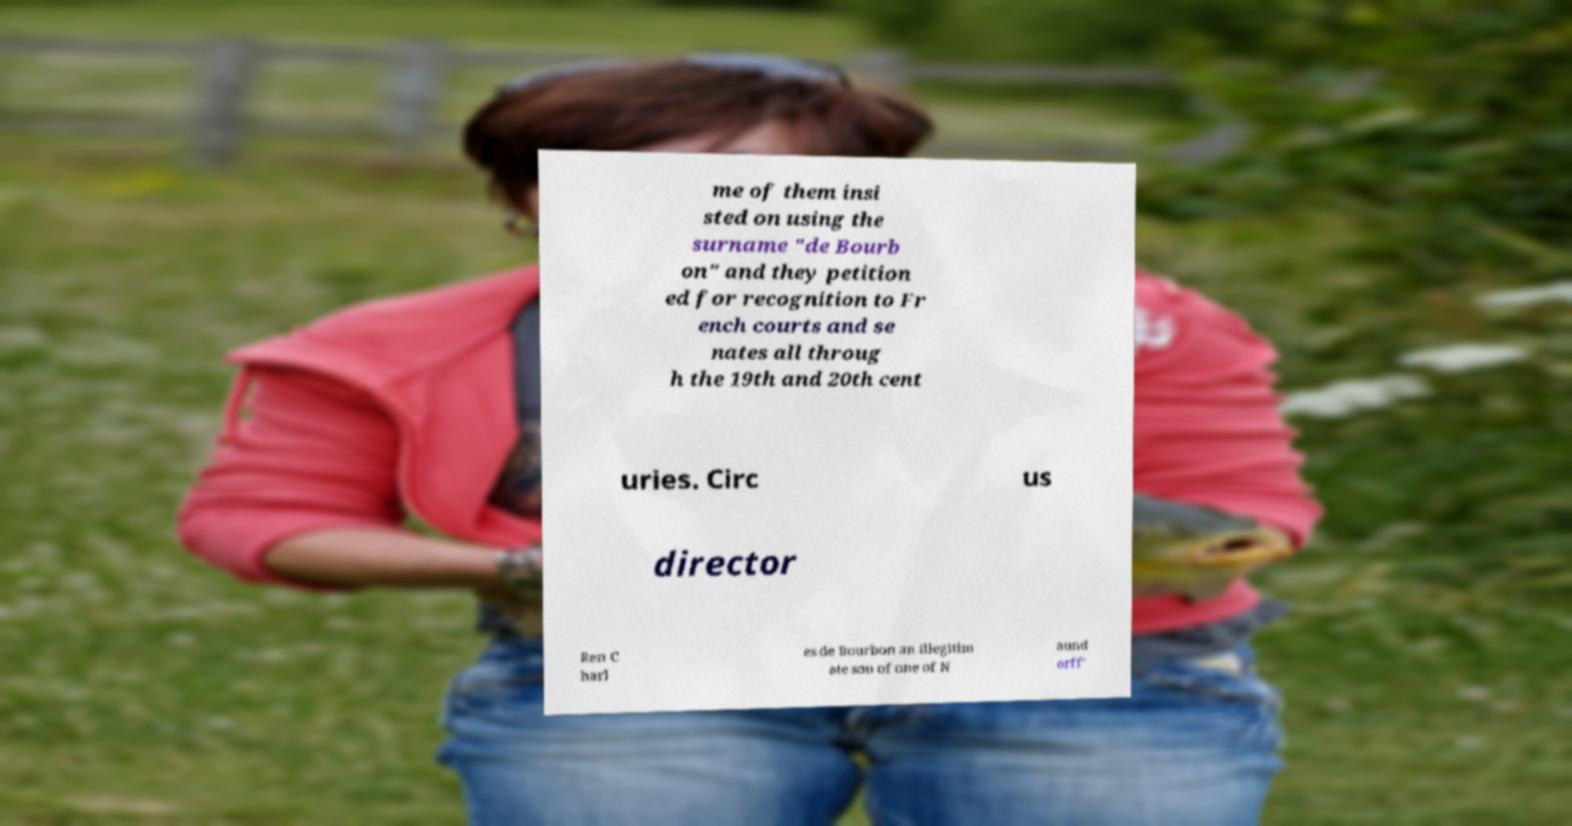I need the written content from this picture converted into text. Can you do that? me of them insi sted on using the surname "de Bourb on" and they petition ed for recognition to Fr ench courts and se nates all throug h the 19th and 20th cent uries. Circ us director Ren C harl es de Bourbon an illegitim ate son of one of N aund orff' 